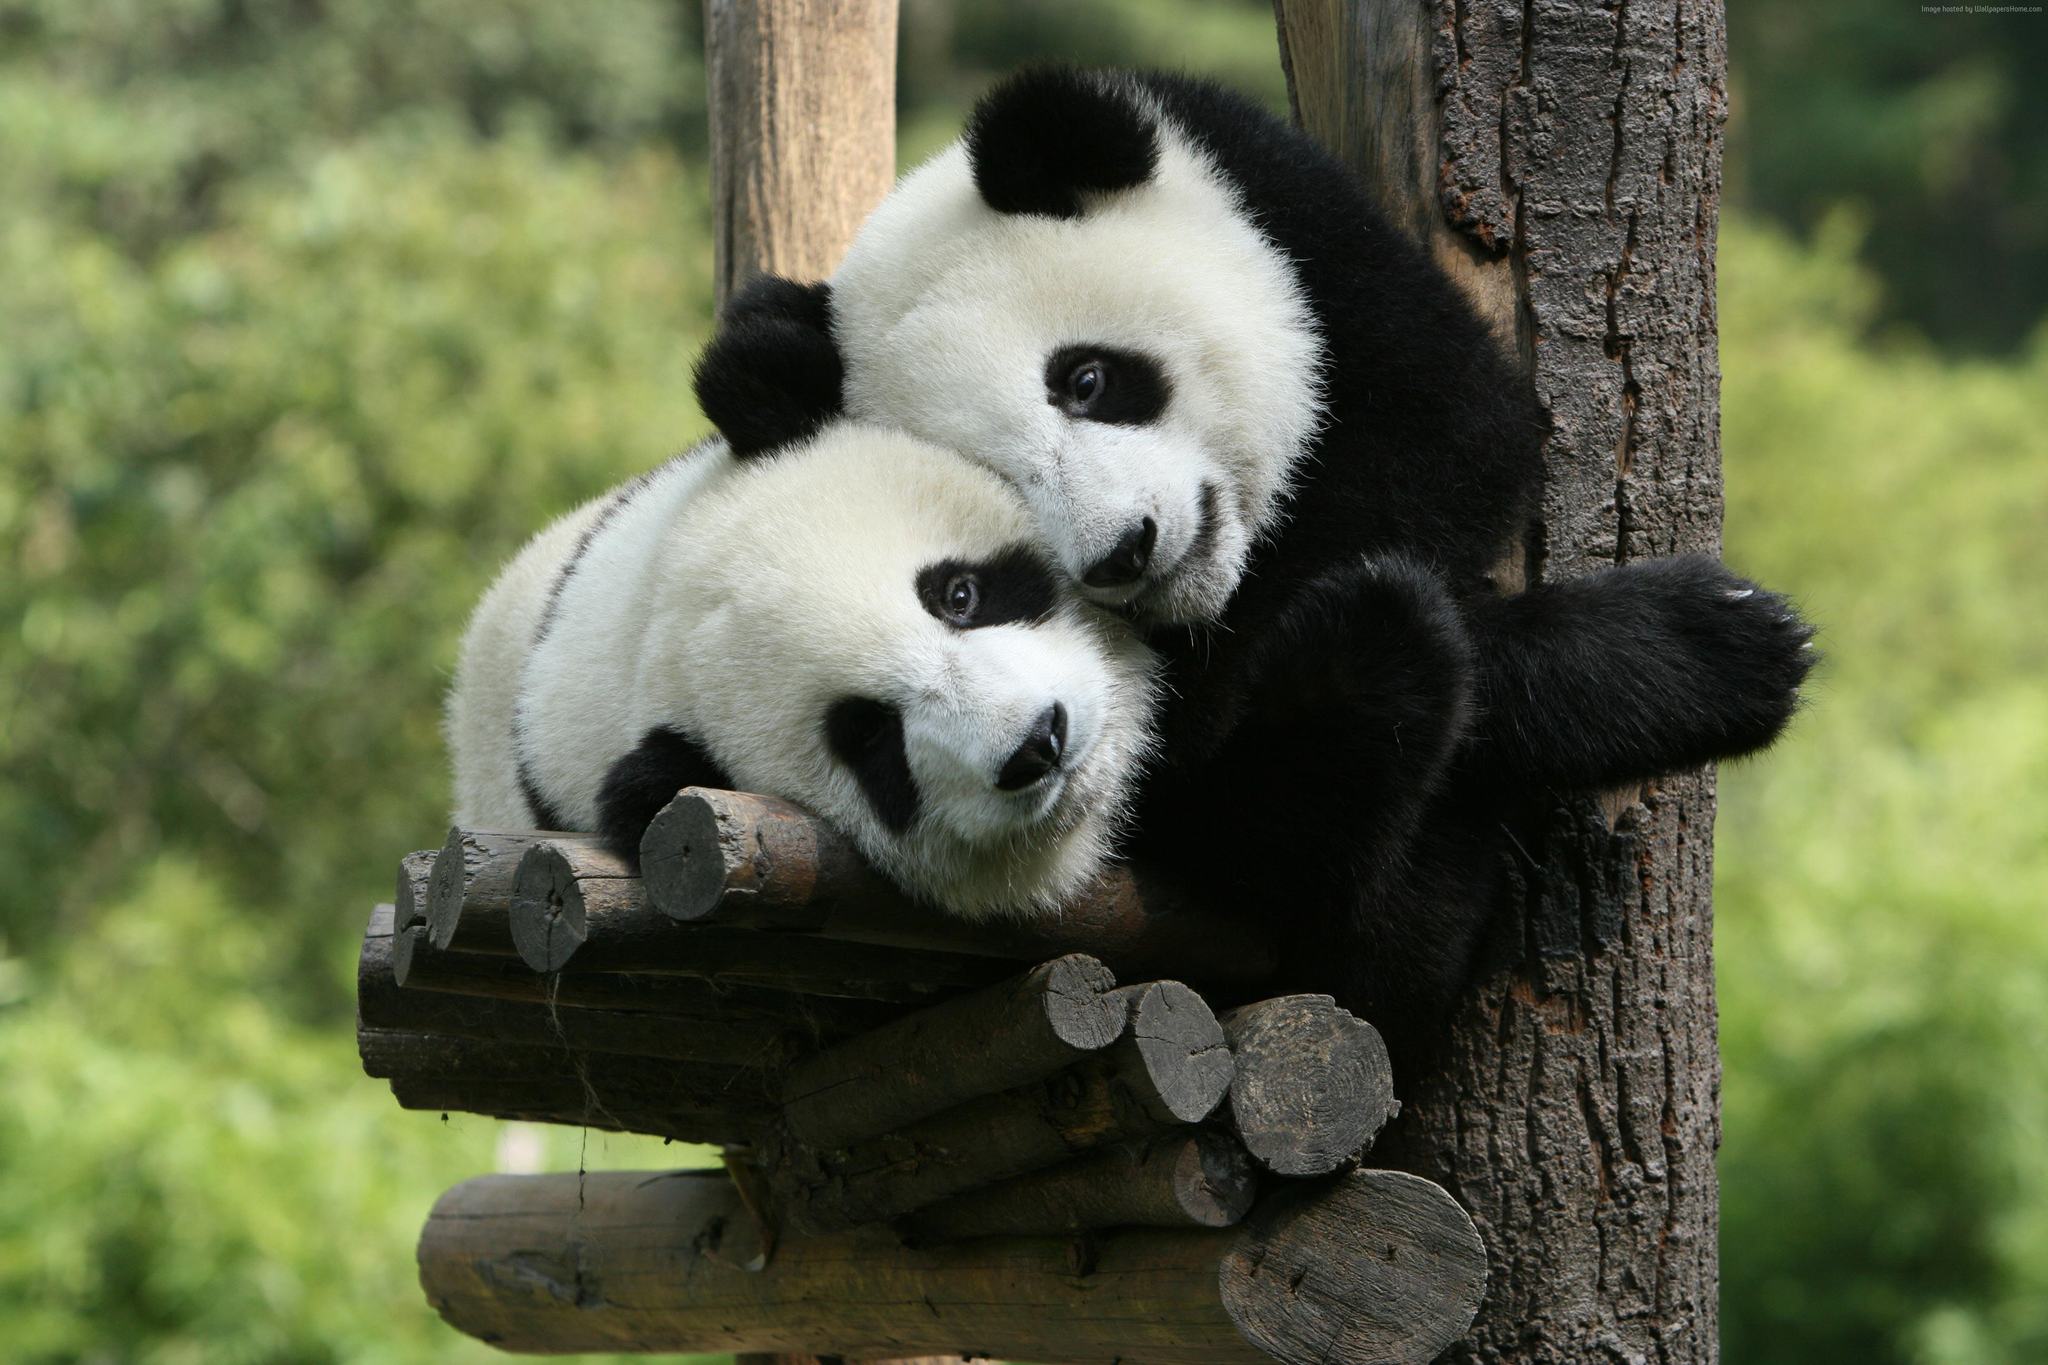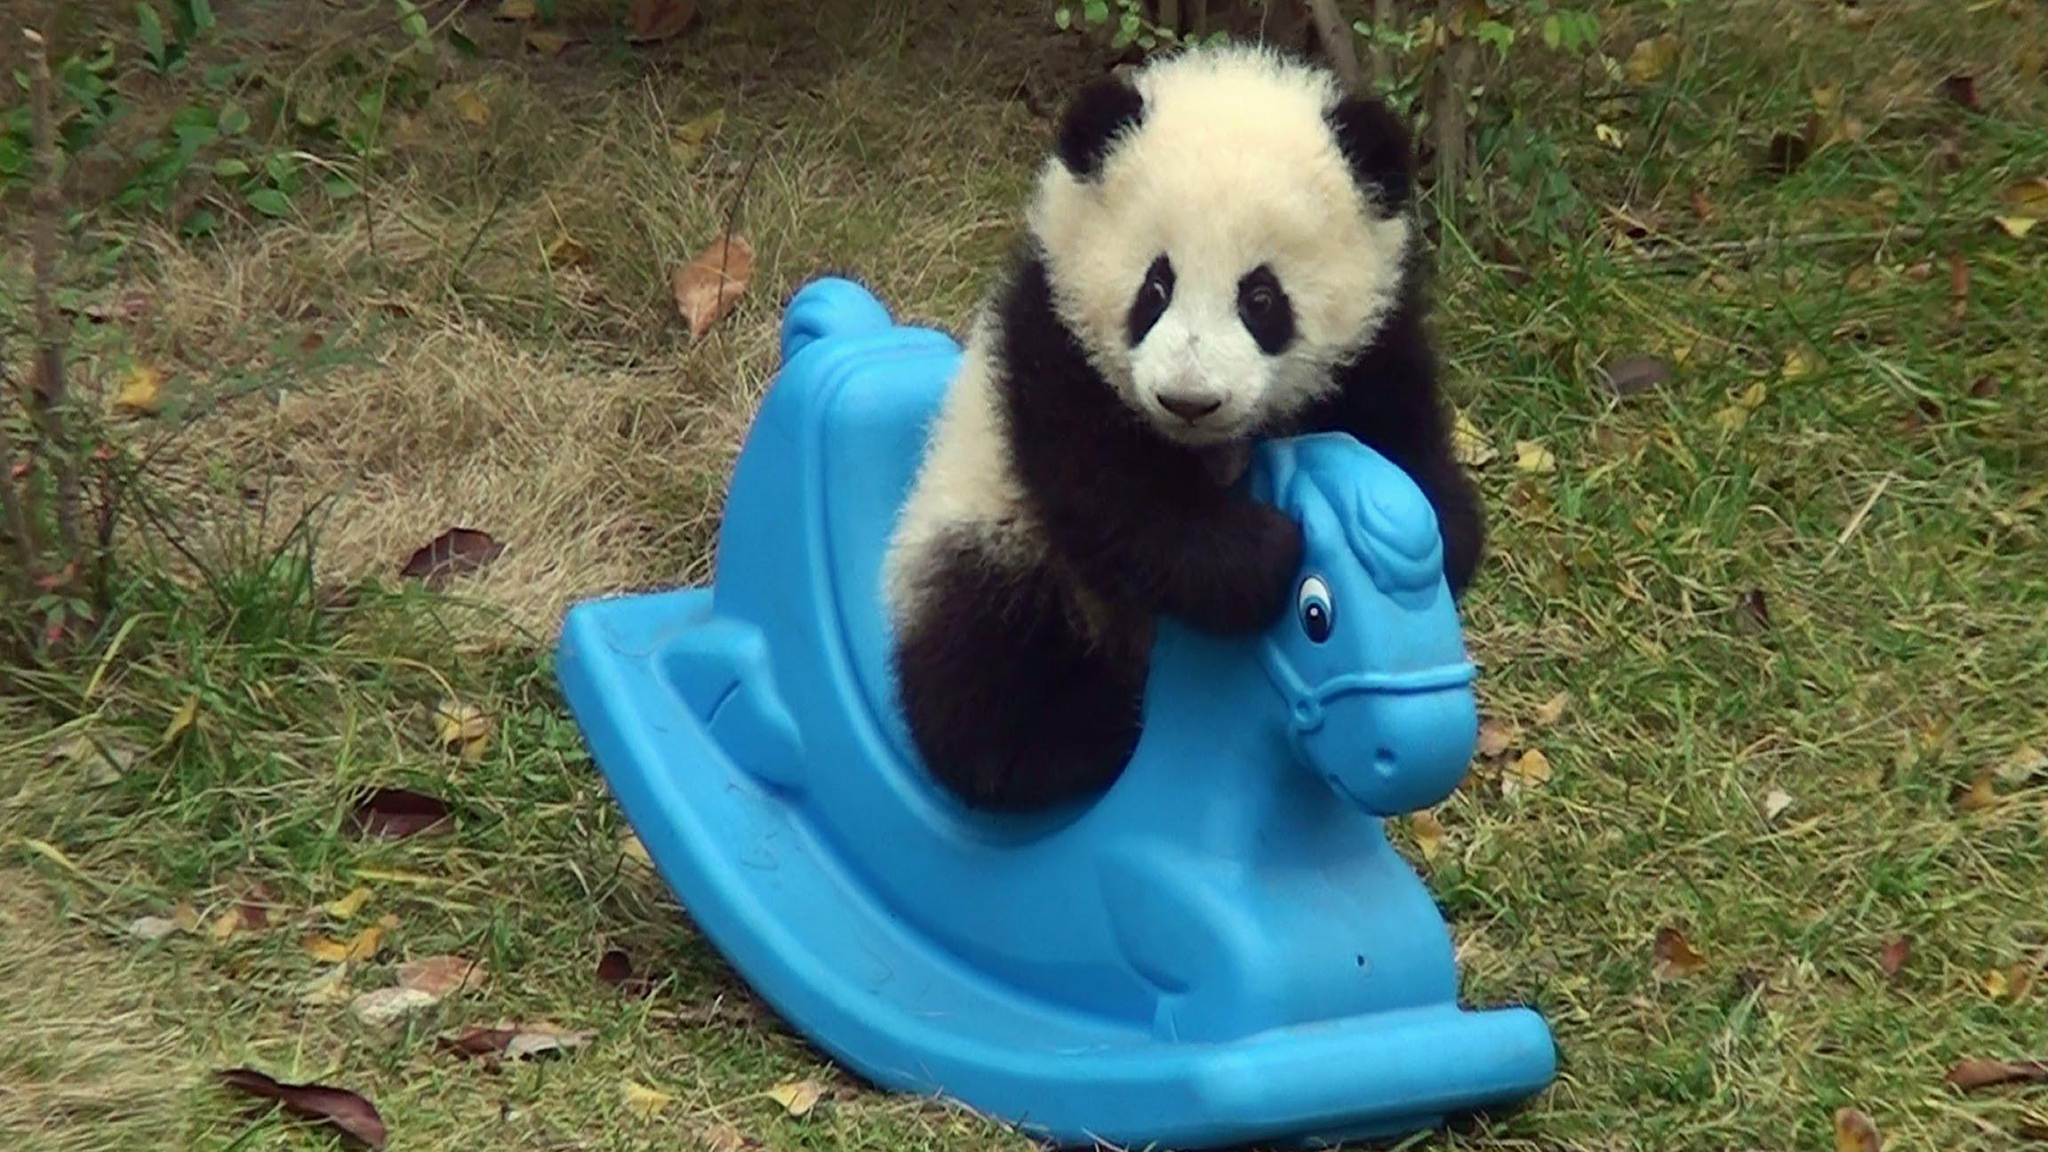The first image is the image on the left, the second image is the image on the right. Analyze the images presented: Is the assertion "In one image, a panda's mouth is open" valid? Answer yes or no. No. The first image is the image on the left, the second image is the image on the right. For the images displayed, is the sentence "In one image, a panda is sitting on something that is not wood." factually correct? Answer yes or no. Yes. 